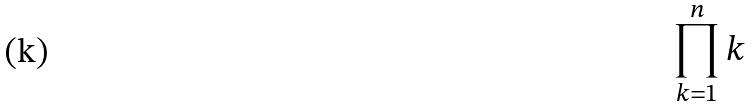Convert formula to latex. <formula><loc_0><loc_0><loc_500><loc_500>\prod _ { k = 1 } ^ { n } k</formula> 